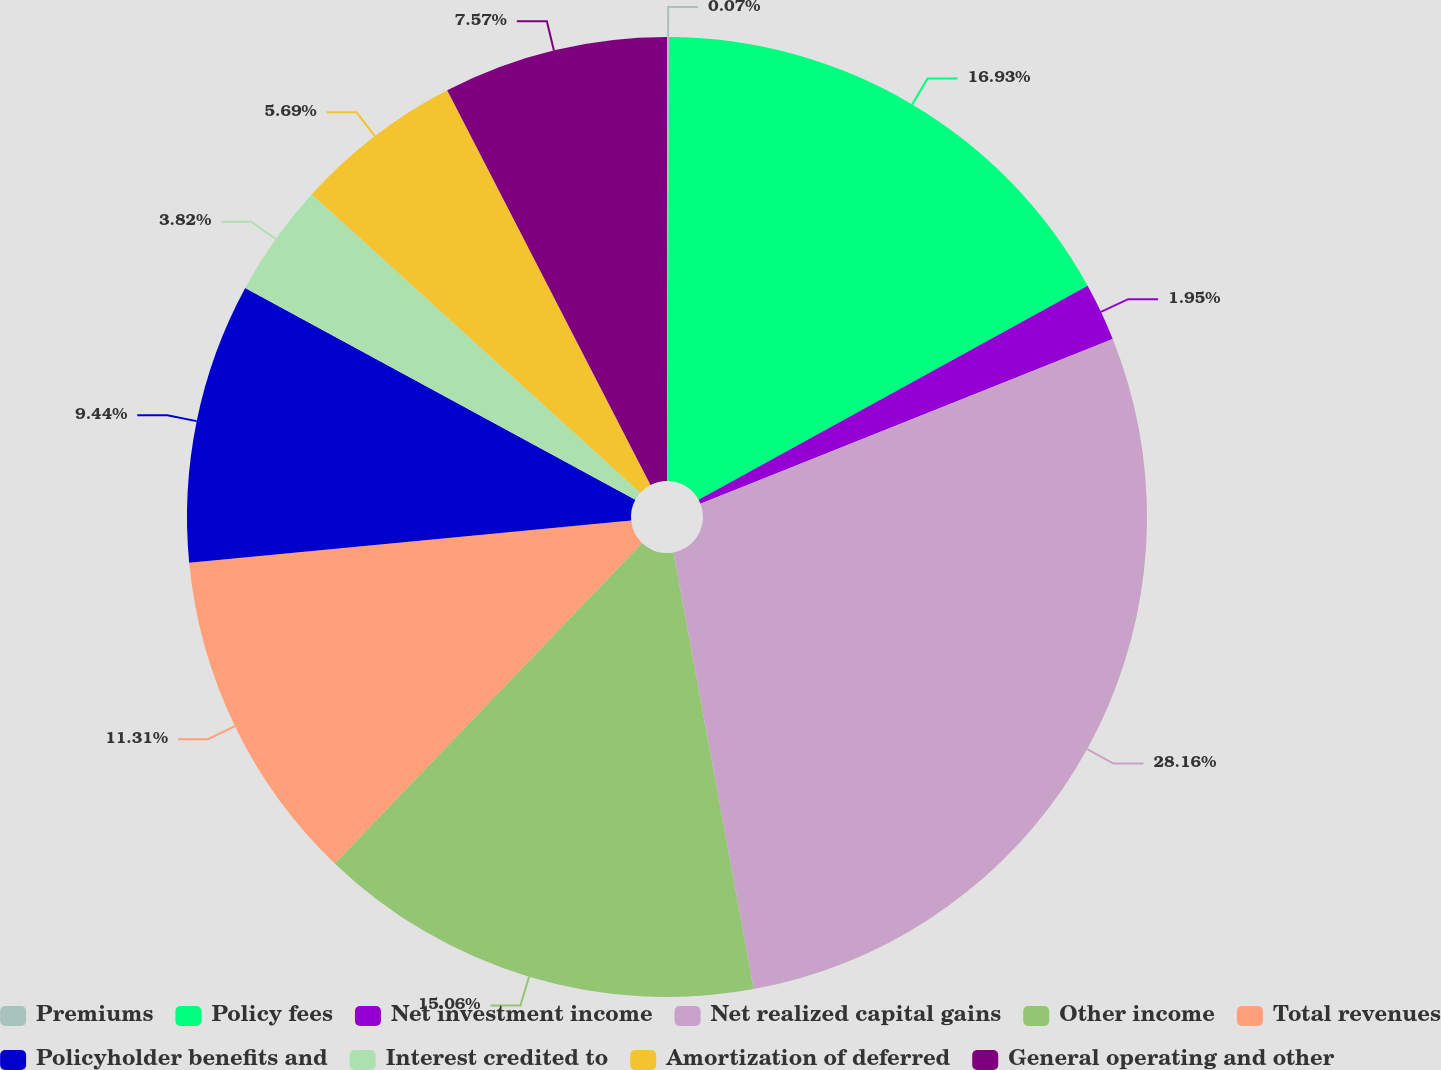Convert chart. <chart><loc_0><loc_0><loc_500><loc_500><pie_chart><fcel>Premiums<fcel>Policy fees<fcel>Net investment income<fcel>Net realized capital gains<fcel>Other income<fcel>Total revenues<fcel>Policyholder benefits and<fcel>Interest credited to<fcel>Amortization of deferred<fcel>General operating and other<nl><fcel>0.07%<fcel>16.93%<fcel>1.95%<fcel>28.16%<fcel>15.06%<fcel>11.31%<fcel>9.44%<fcel>3.82%<fcel>5.69%<fcel>7.57%<nl></chart> 